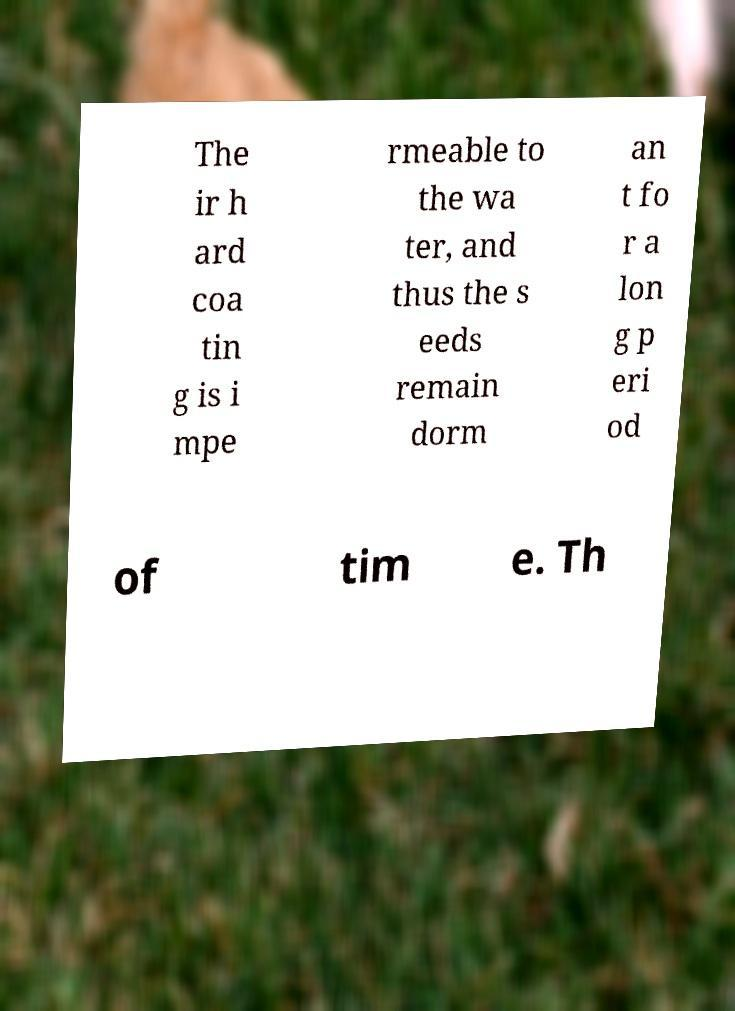Can you accurately transcribe the text from the provided image for me? The ir h ard coa tin g is i mpe rmeable to the wa ter, and thus the s eeds remain dorm an t fo r a lon g p eri od of tim e. Th 